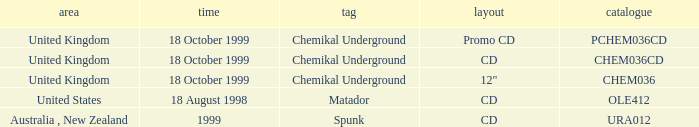What label is associated with the United Kingdom and the chem036 catalog? Chemikal Underground. 